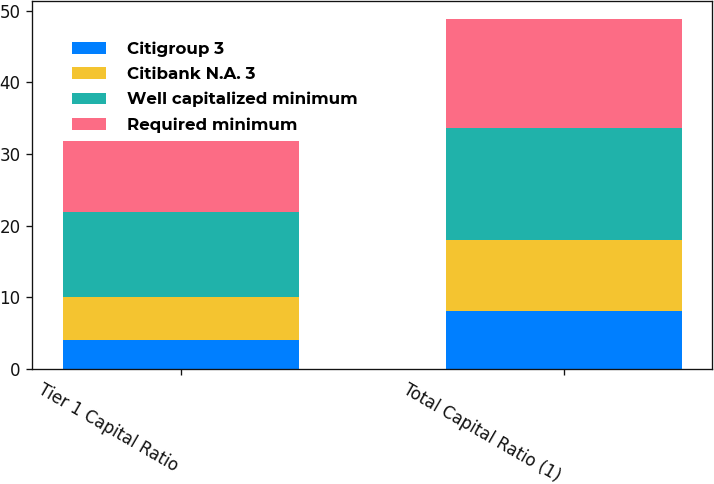<chart> <loc_0><loc_0><loc_500><loc_500><stacked_bar_chart><ecel><fcel>Tier 1 Capital Ratio<fcel>Total Capital Ratio (1)<nl><fcel>Citigroup 3<fcel>4<fcel>8<nl><fcel>Citibank N.A. 3<fcel>6<fcel>10<nl><fcel>Well capitalized minimum<fcel>11.92<fcel>15.7<nl><fcel>Required minimum<fcel>9.94<fcel>15.18<nl></chart> 